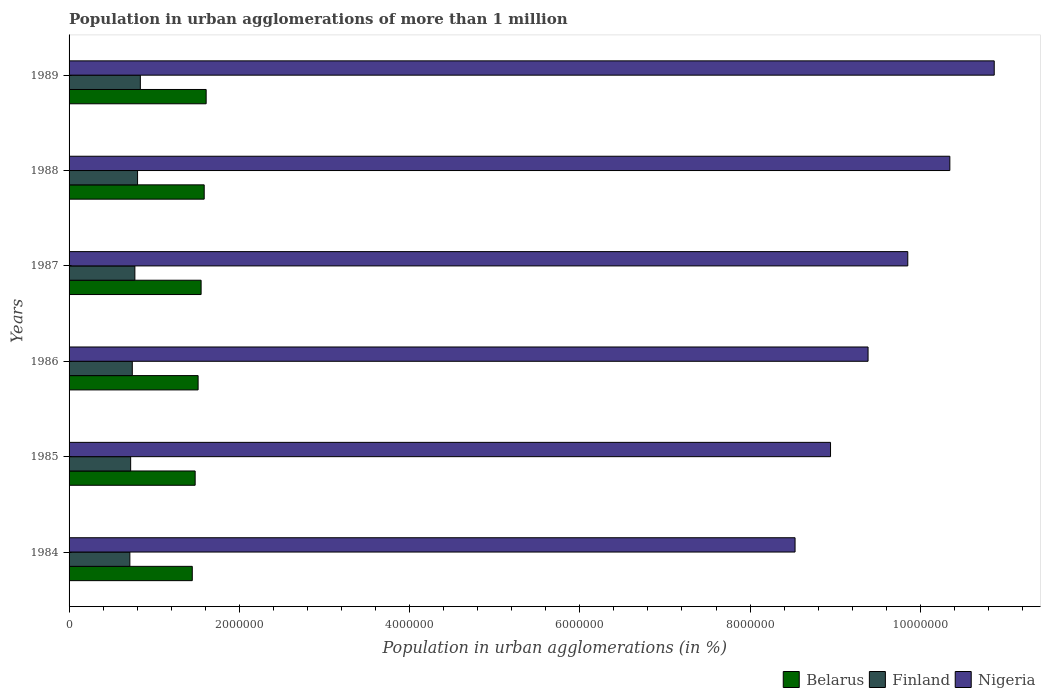Are the number of bars per tick equal to the number of legend labels?
Ensure brevity in your answer.  Yes. Are the number of bars on each tick of the Y-axis equal?
Your answer should be compact. Yes. What is the label of the 4th group of bars from the top?
Offer a terse response. 1986. What is the population in urban agglomerations in Belarus in 1984?
Give a very brief answer. 1.45e+06. Across all years, what is the maximum population in urban agglomerations in Nigeria?
Offer a very short reply. 1.09e+07. Across all years, what is the minimum population in urban agglomerations in Nigeria?
Your answer should be compact. 8.53e+06. In which year was the population in urban agglomerations in Nigeria maximum?
Your answer should be compact. 1989. What is the total population in urban agglomerations in Belarus in the graph?
Your answer should be compact. 9.19e+06. What is the difference between the population in urban agglomerations in Nigeria in 1984 and that in 1985?
Ensure brevity in your answer.  -4.17e+05. What is the difference between the population in urban agglomerations in Finland in 1988 and the population in urban agglomerations in Nigeria in 1986?
Provide a succinct answer. -8.58e+06. What is the average population in urban agglomerations in Finland per year?
Keep it short and to the point. 7.66e+05. In the year 1987, what is the difference between the population in urban agglomerations in Belarus and population in urban agglomerations in Nigeria?
Provide a succinct answer. -8.30e+06. What is the ratio of the population in urban agglomerations in Belarus in 1987 to that in 1988?
Your answer should be compact. 0.98. Is the difference between the population in urban agglomerations in Belarus in 1985 and 1986 greater than the difference between the population in urban agglomerations in Nigeria in 1985 and 1986?
Make the answer very short. Yes. What is the difference between the highest and the second highest population in urban agglomerations in Nigeria?
Give a very brief answer. 5.21e+05. What is the difference between the highest and the lowest population in urban agglomerations in Belarus?
Your answer should be very brief. 1.63e+05. In how many years, is the population in urban agglomerations in Belarus greater than the average population in urban agglomerations in Belarus taken over all years?
Provide a succinct answer. 3. Is the sum of the population in urban agglomerations in Belarus in 1985 and 1988 greater than the maximum population in urban agglomerations in Finland across all years?
Your answer should be very brief. Yes. What does the 1st bar from the top in 1985 represents?
Offer a very short reply. Nigeria. What does the 2nd bar from the bottom in 1985 represents?
Your answer should be compact. Finland. How many bars are there?
Provide a succinct answer. 18. Are all the bars in the graph horizontal?
Provide a succinct answer. Yes. How are the legend labels stacked?
Your response must be concise. Horizontal. What is the title of the graph?
Provide a succinct answer. Population in urban agglomerations of more than 1 million. What is the label or title of the X-axis?
Your response must be concise. Population in urban agglomerations (in %). What is the Population in urban agglomerations (in %) of Belarus in 1984?
Make the answer very short. 1.45e+06. What is the Population in urban agglomerations (in %) of Finland in 1984?
Your answer should be compact. 7.14e+05. What is the Population in urban agglomerations (in %) in Nigeria in 1984?
Your response must be concise. 8.53e+06. What is the Population in urban agglomerations (in %) in Belarus in 1985?
Your answer should be compact. 1.48e+06. What is the Population in urban agglomerations (in %) of Finland in 1985?
Your answer should be very brief. 7.23e+05. What is the Population in urban agglomerations (in %) of Nigeria in 1985?
Ensure brevity in your answer.  8.94e+06. What is the Population in urban agglomerations (in %) of Belarus in 1986?
Give a very brief answer. 1.52e+06. What is the Population in urban agglomerations (in %) of Finland in 1986?
Provide a succinct answer. 7.43e+05. What is the Population in urban agglomerations (in %) in Nigeria in 1986?
Keep it short and to the point. 9.39e+06. What is the Population in urban agglomerations (in %) in Belarus in 1987?
Give a very brief answer. 1.55e+06. What is the Population in urban agglomerations (in %) of Finland in 1987?
Provide a succinct answer. 7.73e+05. What is the Population in urban agglomerations (in %) in Nigeria in 1987?
Give a very brief answer. 9.85e+06. What is the Population in urban agglomerations (in %) of Belarus in 1988?
Provide a short and direct response. 1.59e+06. What is the Population in urban agglomerations (in %) of Finland in 1988?
Offer a terse response. 8.05e+05. What is the Population in urban agglomerations (in %) in Nigeria in 1988?
Keep it short and to the point. 1.03e+07. What is the Population in urban agglomerations (in %) of Belarus in 1989?
Keep it short and to the point. 1.61e+06. What is the Population in urban agglomerations (in %) of Finland in 1989?
Offer a terse response. 8.37e+05. What is the Population in urban agglomerations (in %) of Nigeria in 1989?
Offer a very short reply. 1.09e+07. Across all years, what is the maximum Population in urban agglomerations (in %) of Belarus?
Keep it short and to the point. 1.61e+06. Across all years, what is the maximum Population in urban agglomerations (in %) in Finland?
Ensure brevity in your answer.  8.37e+05. Across all years, what is the maximum Population in urban agglomerations (in %) of Nigeria?
Keep it short and to the point. 1.09e+07. Across all years, what is the minimum Population in urban agglomerations (in %) in Belarus?
Provide a short and direct response. 1.45e+06. Across all years, what is the minimum Population in urban agglomerations (in %) of Finland?
Offer a very short reply. 7.14e+05. Across all years, what is the minimum Population in urban agglomerations (in %) of Nigeria?
Provide a succinct answer. 8.53e+06. What is the total Population in urban agglomerations (in %) in Belarus in the graph?
Ensure brevity in your answer.  9.19e+06. What is the total Population in urban agglomerations (in %) in Finland in the graph?
Your response must be concise. 4.59e+06. What is the total Population in urban agglomerations (in %) of Nigeria in the graph?
Provide a short and direct response. 5.79e+07. What is the difference between the Population in urban agglomerations (in %) of Belarus in 1984 and that in 1985?
Give a very brief answer. -3.38e+04. What is the difference between the Population in urban agglomerations (in %) of Finland in 1984 and that in 1985?
Offer a terse response. -9410. What is the difference between the Population in urban agglomerations (in %) in Nigeria in 1984 and that in 1985?
Provide a succinct answer. -4.17e+05. What is the difference between the Population in urban agglomerations (in %) of Belarus in 1984 and that in 1986?
Offer a terse response. -6.84e+04. What is the difference between the Population in urban agglomerations (in %) in Finland in 1984 and that in 1986?
Your response must be concise. -2.88e+04. What is the difference between the Population in urban agglomerations (in %) in Nigeria in 1984 and that in 1986?
Your response must be concise. -8.58e+05. What is the difference between the Population in urban agglomerations (in %) of Belarus in 1984 and that in 1987?
Your response must be concise. -1.04e+05. What is the difference between the Population in urban agglomerations (in %) of Finland in 1984 and that in 1987?
Your answer should be very brief. -5.90e+04. What is the difference between the Population in urban agglomerations (in %) of Nigeria in 1984 and that in 1987?
Make the answer very short. -1.32e+06. What is the difference between the Population in urban agglomerations (in %) of Belarus in 1984 and that in 1988?
Offer a very short reply. -1.40e+05. What is the difference between the Population in urban agglomerations (in %) of Finland in 1984 and that in 1988?
Give a very brief answer. -9.05e+04. What is the difference between the Population in urban agglomerations (in %) of Nigeria in 1984 and that in 1988?
Provide a short and direct response. -1.82e+06. What is the difference between the Population in urban agglomerations (in %) of Belarus in 1984 and that in 1989?
Offer a terse response. -1.63e+05. What is the difference between the Population in urban agglomerations (in %) in Finland in 1984 and that in 1989?
Your response must be concise. -1.23e+05. What is the difference between the Population in urban agglomerations (in %) of Nigeria in 1984 and that in 1989?
Your answer should be compact. -2.34e+06. What is the difference between the Population in urban agglomerations (in %) in Belarus in 1985 and that in 1986?
Your answer should be very brief. -3.46e+04. What is the difference between the Population in urban agglomerations (in %) of Finland in 1985 and that in 1986?
Provide a succinct answer. -1.94e+04. What is the difference between the Population in urban agglomerations (in %) of Nigeria in 1985 and that in 1986?
Offer a very short reply. -4.41e+05. What is the difference between the Population in urban agglomerations (in %) of Belarus in 1985 and that in 1987?
Provide a short and direct response. -7.00e+04. What is the difference between the Population in urban agglomerations (in %) in Finland in 1985 and that in 1987?
Offer a terse response. -4.96e+04. What is the difference between the Population in urban agglomerations (in %) of Nigeria in 1985 and that in 1987?
Offer a terse response. -9.07e+05. What is the difference between the Population in urban agglomerations (in %) in Belarus in 1985 and that in 1988?
Make the answer very short. -1.06e+05. What is the difference between the Population in urban agglomerations (in %) of Finland in 1985 and that in 1988?
Your response must be concise. -8.11e+04. What is the difference between the Population in urban agglomerations (in %) in Nigeria in 1985 and that in 1988?
Make the answer very short. -1.40e+06. What is the difference between the Population in urban agglomerations (in %) in Belarus in 1985 and that in 1989?
Make the answer very short. -1.29e+05. What is the difference between the Population in urban agglomerations (in %) of Finland in 1985 and that in 1989?
Your answer should be very brief. -1.14e+05. What is the difference between the Population in urban agglomerations (in %) of Nigeria in 1985 and that in 1989?
Give a very brief answer. -1.92e+06. What is the difference between the Population in urban agglomerations (in %) of Belarus in 1986 and that in 1987?
Offer a very short reply. -3.54e+04. What is the difference between the Population in urban agglomerations (in %) in Finland in 1986 and that in 1987?
Offer a terse response. -3.02e+04. What is the difference between the Population in urban agglomerations (in %) in Nigeria in 1986 and that in 1987?
Make the answer very short. -4.66e+05. What is the difference between the Population in urban agglomerations (in %) of Belarus in 1986 and that in 1988?
Give a very brief answer. -7.17e+04. What is the difference between the Population in urban agglomerations (in %) of Finland in 1986 and that in 1988?
Your answer should be compact. -6.17e+04. What is the difference between the Population in urban agglomerations (in %) of Nigeria in 1986 and that in 1988?
Your response must be concise. -9.61e+05. What is the difference between the Population in urban agglomerations (in %) in Belarus in 1986 and that in 1989?
Ensure brevity in your answer.  -9.47e+04. What is the difference between the Population in urban agglomerations (in %) in Finland in 1986 and that in 1989?
Your response must be concise. -9.44e+04. What is the difference between the Population in urban agglomerations (in %) of Nigeria in 1986 and that in 1989?
Your answer should be compact. -1.48e+06. What is the difference between the Population in urban agglomerations (in %) of Belarus in 1987 and that in 1988?
Provide a succinct answer. -3.63e+04. What is the difference between the Population in urban agglomerations (in %) of Finland in 1987 and that in 1988?
Your response must be concise. -3.15e+04. What is the difference between the Population in urban agglomerations (in %) in Nigeria in 1987 and that in 1988?
Make the answer very short. -4.94e+05. What is the difference between the Population in urban agglomerations (in %) in Belarus in 1987 and that in 1989?
Your answer should be compact. -5.92e+04. What is the difference between the Population in urban agglomerations (in %) of Finland in 1987 and that in 1989?
Ensure brevity in your answer.  -6.42e+04. What is the difference between the Population in urban agglomerations (in %) of Nigeria in 1987 and that in 1989?
Your answer should be compact. -1.02e+06. What is the difference between the Population in urban agglomerations (in %) in Belarus in 1988 and that in 1989?
Provide a short and direct response. -2.30e+04. What is the difference between the Population in urban agglomerations (in %) in Finland in 1988 and that in 1989?
Provide a short and direct response. -3.27e+04. What is the difference between the Population in urban agglomerations (in %) in Nigeria in 1988 and that in 1989?
Give a very brief answer. -5.21e+05. What is the difference between the Population in urban agglomerations (in %) in Belarus in 1984 and the Population in urban agglomerations (in %) in Finland in 1985?
Offer a very short reply. 7.24e+05. What is the difference between the Population in urban agglomerations (in %) of Belarus in 1984 and the Population in urban agglomerations (in %) of Nigeria in 1985?
Offer a very short reply. -7.50e+06. What is the difference between the Population in urban agglomerations (in %) of Finland in 1984 and the Population in urban agglomerations (in %) of Nigeria in 1985?
Ensure brevity in your answer.  -8.23e+06. What is the difference between the Population in urban agglomerations (in %) in Belarus in 1984 and the Population in urban agglomerations (in %) in Finland in 1986?
Your response must be concise. 7.05e+05. What is the difference between the Population in urban agglomerations (in %) of Belarus in 1984 and the Population in urban agglomerations (in %) of Nigeria in 1986?
Ensure brevity in your answer.  -7.94e+06. What is the difference between the Population in urban agglomerations (in %) of Finland in 1984 and the Population in urban agglomerations (in %) of Nigeria in 1986?
Offer a terse response. -8.67e+06. What is the difference between the Population in urban agglomerations (in %) of Belarus in 1984 and the Population in urban agglomerations (in %) of Finland in 1987?
Your answer should be compact. 6.74e+05. What is the difference between the Population in urban agglomerations (in %) of Belarus in 1984 and the Population in urban agglomerations (in %) of Nigeria in 1987?
Give a very brief answer. -8.40e+06. What is the difference between the Population in urban agglomerations (in %) in Finland in 1984 and the Population in urban agglomerations (in %) in Nigeria in 1987?
Provide a short and direct response. -9.14e+06. What is the difference between the Population in urban agglomerations (in %) of Belarus in 1984 and the Population in urban agglomerations (in %) of Finland in 1988?
Provide a succinct answer. 6.43e+05. What is the difference between the Population in urban agglomerations (in %) of Belarus in 1984 and the Population in urban agglomerations (in %) of Nigeria in 1988?
Provide a short and direct response. -8.90e+06. What is the difference between the Population in urban agglomerations (in %) of Finland in 1984 and the Population in urban agglomerations (in %) of Nigeria in 1988?
Your response must be concise. -9.63e+06. What is the difference between the Population in urban agglomerations (in %) of Belarus in 1984 and the Population in urban agglomerations (in %) of Finland in 1989?
Your answer should be very brief. 6.10e+05. What is the difference between the Population in urban agglomerations (in %) of Belarus in 1984 and the Population in urban agglomerations (in %) of Nigeria in 1989?
Make the answer very short. -9.42e+06. What is the difference between the Population in urban agglomerations (in %) in Finland in 1984 and the Population in urban agglomerations (in %) in Nigeria in 1989?
Your response must be concise. -1.02e+07. What is the difference between the Population in urban agglomerations (in %) in Belarus in 1985 and the Population in urban agglomerations (in %) in Finland in 1986?
Your answer should be compact. 7.38e+05. What is the difference between the Population in urban agglomerations (in %) in Belarus in 1985 and the Population in urban agglomerations (in %) in Nigeria in 1986?
Make the answer very short. -7.90e+06. What is the difference between the Population in urban agglomerations (in %) of Finland in 1985 and the Population in urban agglomerations (in %) of Nigeria in 1986?
Offer a very short reply. -8.66e+06. What is the difference between the Population in urban agglomerations (in %) of Belarus in 1985 and the Population in urban agglomerations (in %) of Finland in 1987?
Your answer should be compact. 7.08e+05. What is the difference between the Population in urban agglomerations (in %) of Belarus in 1985 and the Population in urban agglomerations (in %) of Nigeria in 1987?
Ensure brevity in your answer.  -8.37e+06. What is the difference between the Population in urban agglomerations (in %) in Finland in 1985 and the Population in urban agglomerations (in %) in Nigeria in 1987?
Ensure brevity in your answer.  -9.13e+06. What is the difference between the Population in urban agglomerations (in %) of Belarus in 1985 and the Population in urban agglomerations (in %) of Finland in 1988?
Give a very brief answer. 6.77e+05. What is the difference between the Population in urban agglomerations (in %) of Belarus in 1985 and the Population in urban agglomerations (in %) of Nigeria in 1988?
Give a very brief answer. -8.87e+06. What is the difference between the Population in urban agglomerations (in %) in Finland in 1985 and the Population in urban agglomerations (in %) in Nigeria in 1988?
Provide a succinct answer. -9.62e+06. What is the difference between the Population in urban agglomerations (in %) in Belarus in 1985 and the Population in urban agglomerations (in %) in Finland in 1989?
Offer a very short reply. 6.44e+05. What is the difference between the Population in urban agglomerations (in %) in Belarus in 1985 and the Population in urban agglomerations (in %) in Nigeria in 1989?
Provide a succinct answer. -9.39e+06. What is the difference between the Population in urban agglomerations (in %) in Finland in 1985 and the Population in urban agglomerations (in %) in Nigeria in 1989?
Your response must be concise. -1.01e+07. What is the difference between the Population in urban agglomerations (in %) in Belarus in 1986 and the Population in urban agglomerations (in %) in Finland in 1987?
Your response must be concise. 7.43e+05. What is the difference between the Population in urban agglomerations (in %) of Belarus in 1986 and the Population in urban agglomerations (in %) of Nigeria in 1987?
Your answer should be compact. -8.34e+06. What is the difference between the Population in urban agglomerations (in %) in Finland in 1986 and the Population in urban agglomerations (in %) in Nigeria in 1987?
Give a very brief answer. -9.11e+06. What is the difference between the Population in urban agglomerations (in %) of Belarus in 1986 and the Population in urban agglomerations (in %) of Finland in 1988?
Your response must be concise. 7.11e+05. What is the difference between the Population in urban agglomerations (in %) of Belarus in 1986 and the Population in urban agglomerations (in %) of Nigeria in 1988?
Your answer should be compact. -8.83e+06. What is the difference between the Population in urban agglomerations (in %) of Finland in 1986 and the Population in urban agglomerations (in %) of Nigeria in 1988?
Offer a terse response. -9.60e+06. What is the difference between the Population in urban agglomerations (in %) in Belarus in 1986 and the Population in urban agglomerations (in %) in Finland in 1989?
Offer a terse response. 6.79e+05. What is the difference between the Population in urban agglomerations (in %) of Belarus in 1986 and the Population in urban agglomerations (in %) of Nigeria in 1989?
Offer a terse response. -9.35e+06. What is the difference between the Population in urban agglomerations (in %) of Finland in 1986 and the Population in urban agglomerations (in %) of Nigeria in 1989?
Give a very brief answer. -1.01e+07. What is the difference between the Population in urban agglomerations (in %) in Belarus in 1987 and the Population in urban agglomerations (in %) in Finland in 1988?
Your answer should be very brief. 7.47e+05. What is the difference between the Population in urban agglomerations (in %) of Belarus in 1987 and the Population in urban agglomerations (in %) of Nigeria in 1988?
Offer a terse response. -8.80e+06. What is the difference between the Population in urban agglomerations (in %) of Finland in 1987 and the Population in urban agglomerations (in %) of Nigeria in 1988?
Offer a very short reply. -9.57e+06. What is the difference between the Population in urban agglomerations (in %) in Belarus in 1987 and the Population in urban agglomerations (in %) in Finland in 1989?
Ensure brevity in your answer.  7.14e+05. What is the difference between the Population in urban agglomerations (in %) of Belarus in 1987 and the Population in urban agglomerations (in %) of Nigeria in 1989?
Provide a succinct answer. -9.32e+06. What is the difference between the Population in urban agglomerations (in %) in Finland in 1987 and the Population in urban agglomerations (in %) in Nigeria in 1989?
Your answer should be compact. -1.01e+07. What is the difference between the Population in urban agglomerations (in %) of Belarus in 1988 and the Population in urban agglomerations (in %) of Finland in 1989?
Offer a very short reply. 7.50e+05. What is the difference between the Population in urban agglomerations (in %) in Belarus in 1988 and the Population in urban agglomerations (in %) in Nigeria in 1989?
Your answer should be very brief. -9.28e+06. What is the difference between the Population in urban agglomerations (in %) of Finland in 1988 and the Population in urban agglomerations (in %) of Nigeria in 1989?
Ensure brevity in your answer.  -1.01e+07. What is the average Population in urban agglomerations (in %) in Belarus per year?
Your response must be concise. 1.53e+06. What is the average Population in urban agglomerations (in %) of Finland per year?
Make the answer very short. 7.66e+05. What is the average Population in urban agglomerations (in %) in Nigeria per year?
Provide a succinct answer. 9.65e+06. In the year 1984, what is the difference between the Population in urban agglomerations (in %) in Belarus and Population in urban agglomerations (in %) in Finland?
Offer a very short reply. 7.33e+05. In the year 1984, what is the difference between the Population in urban agglomerations (in %) of Belarus and Population in urban agglomerations (in %) of Nigeria?
Offer a very short reply. -7.08e+06. In the year 1984, what is the difference between the Population in urban agglomerations (in %) of Finland and Population in urban agglomerations (in %) of Nigeria?
Ensure brevity in your answer.  -7.81e+06. In the year 1985, what is the difference between the Population in urban agglomerations (in %) in Belarus and Population in urban agglomerations (in %) in Finland?
Your answer should be compact. 7.58e+05. In the year 1985, what is the difference between the Population in urban agglomerations (in %) of Belarus and Population in urban agglomerations (in %) of Nigeria?
Give a very brief answer. -7.46e+06. In the year 1985, what is the difference between the Population in urban agglomerations (in %) in Finland and Population in urban agglomerations (in %) in Nigeria?
Offer a very short reply. -8.22e+06. In the year 1986, what is the difference between the Population in urban agglomerations (in %) of Belarus and Population in urban agglomerations (in %) of Finland?
Offer a very short reply. 7.73e+05. In the year 1986, what is the difference between the Population in urban agglomerations (in %) of Belarus and Population in urban agglomerations (in %) of Nigeria?
Keep it short and to the point. -7.87e+06. In the year 1986, what is the difference between the Population in urban agglomerations (in %) of Finland and Population in urban agglomerations (in %) of Nigeria?
Make the answer very short. -8.64e+06. In the year 1987, what is the difference between the Population in urban agglomerations (in %) of Belarus and Population in urban agglomerations (in %) of Finland?
Offer a terse response. 7.78e+05. In the year 1987, what is the difference between the Population in urban agglomerations (in %) of Belarus and Population in urban agglomerations (in %) of Nigeria?
Your answer should be compact. -8.30e+06. In the year 1987, what is the difference between the Population in urban agglomerations (in %) of Finland and Population in urban agglomerations (in %) of Nigeria?
Keep it short and to the point. -9.08e+06. In the year 1988, what is the difference between the Population in urban agglomerations (in %) in Belarus and Population in urban agglomerations (in %) in Finland?
Ensure brevity in your answer.  7.83e+05. In the year 1988, what is the difference between the Population in urban agglomerations (in %) of Belarus and Population in urban agglomerations (in %) of Nigeria?
Give a very brief answer. -8.76e+06. In the year 1988, what is the difference between the Population in urban agglomerations (in %) in Finland and Population in urban agglomerations (in %) in Nigeria?
Give a very brief answer. -9.54e+06. In the year 1989, what is the difference between the Population in urban agglomerations (in %) in Belarus and Population in urban agglomerations (in %) in Finland?
Give a very brief answer. 7.73e+05. In the year 1989, what is the difference between the Population in urban agglomerations (in %) of Belarus and Population in urban agglomerations (in %) of Nigeria?
Give a very brief answer. -9.26e+06. In the year 1989, what is the difference between the Population in urban agglomerations (in %) of Finland and Population in urban agglomerations (in %) of Nigeria?
Your answer should be very brief. -1.00e+07. What is the ratio of the Population in urban agglomerations (in %) in Belarus in 1984 to that in 1985?
Provide a succinct answer. 0.98. What is the ratio of the Population in urban agglomerations (in %) in Finland in 1984 to that in 1985?
Provide a succinct answer. 0.99. What is the ratio of the Population in urban agglomerations (in %) of Nigeria in 1984 to that in 1985?
Make the answer very short. 0.95. What is the ratio of the Population in urban agglomerations (in %) of Belarus in 1984 to that in 1986?
Make the answer very short. 0.95. What is the ratio of the Population in urban agglomerations (in %) of Finland in 1984 to that in 1986?
Make the answer very short. 0.96. What is the ratio of the Population in urban agglomerations (in %) in Nigeria in 1984 to that in 1986?
Give a very brief answer. 0.91. What is the ratio of the Population in urban agglomerations (in %) in Belarus in 1984 to that in 1987?
Make the answer very short. 0.93. What is the ratio of the Population in urban agglomerations (in %) in Finland in 1984 to that in 1987?
Make the answer very short. 0.92. What is the ratio of the Population in urban agglomerations (in %) of Nigeria in 1984 to that in 1987?
Give a very brief answer. 0.87. What is the ratio of the Population in urban agglomerations (in %) in Belarus in 1984 to that in 1988?
Keep it short and to the point. 0.91. What is the ratio of the Population in urban agglomerations (in %) in Finland in 1984 to that in 1988?
Your answer should be very brief. 0.89. What is the ratio of the Population in urban agglomerations (in %) of Nigeria in 1984 to that in 1988?
Provide a short and direct response. 0.82. What is the ratio of the Population in urban agglomerations (in %) in Belarus in 1984 to that in 1989?
Your answer should be compact. 0.9. What is the ratio of the Population in urban agglomerations (in %) in Finland in 1984 to that in 1989?
Provide a short and direct response. 0.85. What is the ratio of the Population in urban agglomerations (in %) in Nigeria in 1984 to that in 1989?
Your answer should be compact. 0.78. What is the ratio of the Population in urban agglomerations (in %) of Belarus in 1985 to that in 1986?
Make the answer very short. 0.98. What is the ratio of the Population in urban agglomerations (in %) of Finland in 1985 to that in 1986?
Give a very brief answer. 0.97. What is the ratio of the Population in urban agglomerations (in %) in Nigeria in 1985 to that in 1986?
Make the answer very short. 0.95. What is the ratio of the Population in urban agglomerations (in %) of Belarus in 1985 to that in 1987?
Keep it short and to the point. 0.95. What is the ratio of the Population in urban agglomerations (in %) in Finland in 1985 to that in 1987?
Your response must be concise. 0.94. What is the ratio of the Population in urban agglomerations (in %) in Nigeria in 1985 to that in 1987?
Offer a terse response. 0.91. What is the ratio of the Population in urban agglomerations (in %) of Belarus in 1985 to that in 1988?
Offer a very short reply. 0.93. What is the ratio of the Population in urban agglomerations (in %) of Finland in 1985 to that in 1988?
Offer a very short reply. 0.9. What is the ratio of the Population in urban agglomerations (in %) in Nigeria in 1985 to that in 1988?
Provide a short and direct response. 0.86. What is the ratio of the Population in urban agglomerations (in %) in Belarus in 1985 to that in 1989?
Offer a terse response. 0.92. What is the ratio of the Population in urban agglomerations (in %) in Finland in 1985 to that in 1989?
Your answer should be very brief. 0.86. What is the ratio of the Population in urban agglomerations (in %) of Nigeria in 1985 to that in 1989?
Provide a short and direct response. 0.82. What is the ratio of the Population in urban agglomerations (in %) in Belarus in 1986 to that in 1987?
Give a very brief answer. 0.98. What is the ratio of the Population in urban agglomerations (in %) in Finland in 1986 to that in 1987?
Make the answer very short. 0.96. What is the ratio of the Population in urban agglomerations (in %) of Nigeria in 1986 to that in 1987?
Your response must be concise. 0.95. What is the ratio of the Population in urban agglomerations (in %) of Belarus in 1986 to that in 1988?
Provide a short and direct response. 0.95. What is the ratio of the Population in urban agglomerations (in %) in Finland in 1986 to that in 1988?
Give a very brief answer. 0.92. What is the ratio of the Population in urban agglomerations (in %) of Nigeria in 1986 to that in 1988?
Your response must be concise. 0.91. What is the ratio of the Population in urban agglomerations (in %) of Belarus in 1986 to that in 1989?
Ensure brevity in your answer.  0.94. What is the ratio of the Population in urban agglomerations (in %) of Finland in 1986 to that in 1989?
Provide a short and direct response. 0.89. What is the ratio of the Population in urban agglomerations (in %) in Nigeria in 1986 to that in 1989?
Make the answer very short. 0.86. What is the ratio of the Population in urban agglomerations (in %) in Belarus in 1987 to that in 1988?
Your answer should be compact. 0.98. What is the ratio of the Population in urban agglomerations (in %) in Finland in 1987 to that in 1988?
Offer a terse response. 0.96. What is the ratio of the Population in urban agglomerations (in %) of Nigeria in 1987 to that in 1988?
Make the answer very short. 0.95. What is the ratio of the Population in urban agglomerations (in %) of Belarus in 1987 to that in 1989?
Your answer should be very brief. 0.96. What is the ratio of the Population in urban agglomerations (in %) of Finland in 1987 to that in 1989?
Make the answer very short. 0.92. What is the ratio of the Population in urban agglomerations (in %) of Nigeria in 1987 to that in 1989?
Provide a succinct answer. 0.91. What is the ratio of the Population in urban agglomerations (in %) of Belarus in 1988 to that in 1989?
Give a very brief answer. 0.99. What is the difference between the highest and the second highest Population in urban agglomerations (in %) of Belarus?
Offer a terse response. 2.30e+04. What is the difference between the highest and the second highest Population in urban agglomerations (in %) in Finland?
Give a very brief answer. 3.27e+04. What is the difference between the highest and the second highest Population in urban agglomerations (in %) in Nigeria?
Make the answer very short. 5.21e+05. What is the difference between the highest and the lowest Population in urban agglomerations (in %) of Belarus?
Give a very brief answer. 1.63e+05. What is the difference between the highest and the lowest Population in urban agglomerations (in %) of Finland?
Give a very brief answer. 1.23e+05. What is the difference between the highest and the lowest Population in urban agglomerations (in %) in Nigeria?
Offer a terse response. 2.34e+06. 